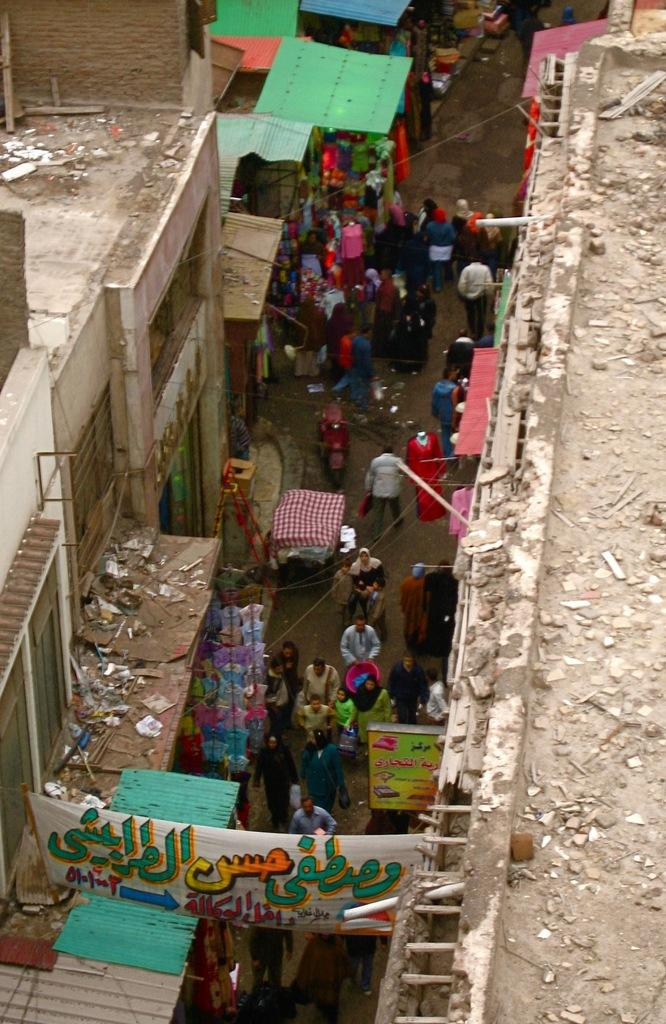What type of structures can be seen in the image? There are roofs of buildings visible in the image. What else can be seen in the image besides the buildings? The street is visible in the image. Are there any decorations or signs in the image? Yes, there are banners in the image. What is happening on the street in the image? There are persons walking on the street in the image. Can you see any birds smiling in the image? There are no birds or smiles present in the image. 